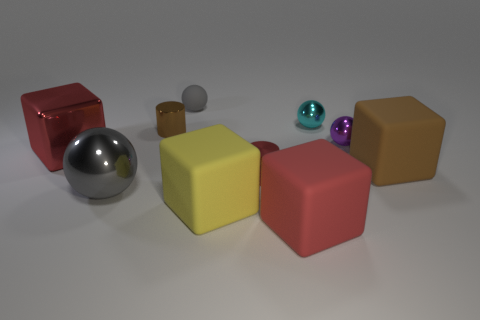How many objects are there in total? Including all the spheres and blocks, there are a total of seven objects. 